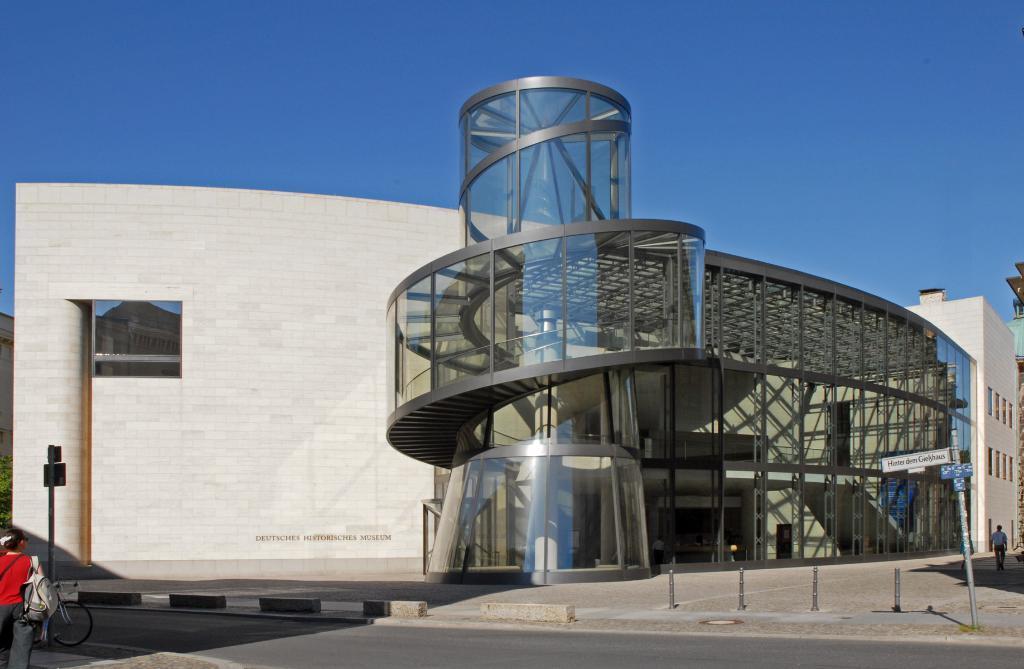How would you summarize this image in a sentence or two? There is a construction with a glass and metal bars all over and there is brick wall over here which is white colored bricks. There is a woman standing over here at the left bottom and watching this construction and it is written as a Museum at the bottom on the wall. 